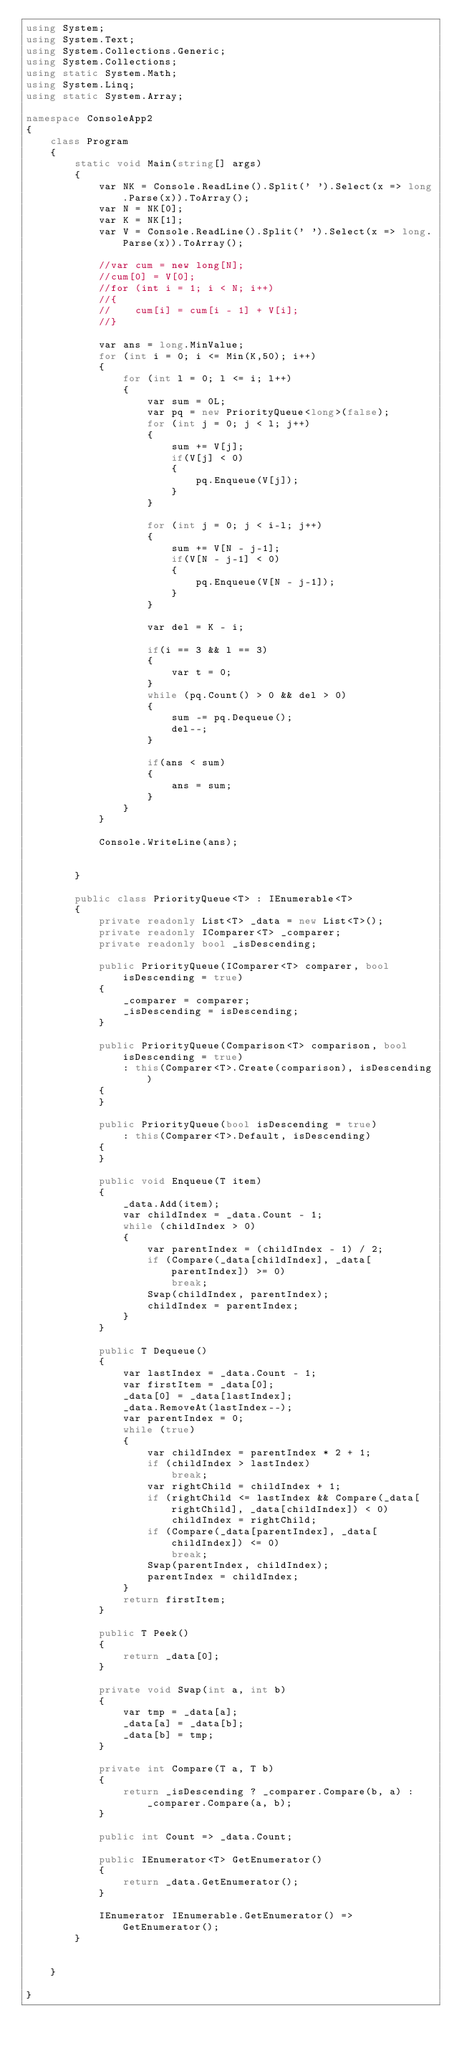<code> <loc_0><loc_0><loc_500><loc_500><_C#_>using System;
using System.Text;
using System.Collections.Generic;
using System.Collections;
using static System.Math;
using System.Linq;
using static System.Array;

namespace ConsoleApp2
{
    class Program
    {
        static void Main(string[] args)
        {
            var NK = Console.ReadLine().Split(' ').Select(x => long.Parse(x)).ToArray();
            var N = NK[0];
            var K = NK[1];
            var V = Console.ReadLine().Split(' ').Select(x => long.Parse(x)).ToArray();

            //var cum = new long[N];
            //cum[0] = V[0];
            //for (int i = 1; i < N; i++)
            //{
            //    cum[i] = cum[i - 1] + V[i];
            //}

            var ans = long.MinValue;
            for (int i = 0; i <= Min(K,50); i++)
            {
                for (int l = 0; l <= i; l++)
                {
                    var sum = 0L;
                    var pq = new PriorityQueue<long>(false);
                    for (int j = 0; j < l; j++)
                    {
                        sum += V[j];
                        if(V[j] < 0)
                        {
                            pq.Enqueue(V[j]);
                        }
                    }

                    for (int j = 0; j < i-l; j++)
                    {
                        sum += V[N - j-1];
                        if(V[N - j-1] < 0)
                        {
                            pq.Enqueue(V[N - j-1]);
                        }
                    }

                    var del = K - i;

                    if(i == 3 && l == 3)
                    {
                        var t = 0;
                    }
                    while (pq.Count() > 0 && del > 0)
                    {
                        sum -= pq.Dequeue();
                        del--;
                    }

                    if(ans < sum)
                    {
                        ans = sum;
                    }
                }
            }

            Console.WriteLine(ans);

            
        }

        public class PriorityQueue<T> : IEnumerable<T>
        {
            private readonly List<T> _data = new List<T>();
            private readonly IComparer<T> _comparer;
            private readonly bool _isDescending;

            public PriorityQueue(IComparer<T> comparer, bool isDescending = true)
            {
                _comparer = comparer;
                _isDescending = isDescending;
            }

            public PriorityQueue(Comparison<T> comparison, bool isDescending = true)
                : this(Comparer<T>.Create(comparison), isDescending)
            {
            }

            public PriorityQueue(bool isDescending = true)
                : this(Comparer<T>.Default, isDescending)
            {
            }

            public void Enqueue(T item)
            {
                _data.Add(item);
                var childIndex = _data.Count - 1;
                while (childIndex > 0)
                {
                    var parentIndex = (childIndex - 1) / 2;
                    if (Compare(_data[childIndex], _data[parentIndex]) >= 0)
                        break;
                    Swap(childIndex, parentIndex);
                    childIndex = parentIndex;
                }
            }

            public T Dequeue()
            {
                var lastIndex = _data.Count - 1;
                var firstItem = _data[0];
                _data[0] = _data[lastIndex];
                _data.RemoveAt(lastIndex--);
                var parentIndex = 0;
                while (true)
                {
                    var childIndex = parentIndex * 2 + 1;
                    if (childIndex > lastIndex)
                        break;
                    var rightChild = childIndex + 1;
                    if (rightChild <= lastIndex && Compare(_data[rightChild], _data[childIndex]) < 0)
                        childIndex = rightChild;
                    if (Compare(_data[parentIndex], _data[childIndex]) <= 0)
                        break;
                    Swap(parentIndex, childIndex);
                    parentIndex = childIndex;
                }
                return firstItem;
            }

            public T Peek()
            {
                return _data[0];
            }

            private void Swap(int a, int b)
            {
                var tmp = _data[a];
                _data[a] = _data[b];
                _data[b] = tmp;
            }

            private int Compare(T a, T b)
            {
                return _isDescending ? _comparer.Compare(b, a) : _comparer.Compare(a, b);
            }

            public int Count => _data.Count;

            public IEnumerator<T> GetEnumerator()
            {
                return _data.GetEnumerator();
            }

            IEnumerator IEnumerable.GetEnumerator() => GetEnumerator();
        }


    }

}
</code> 